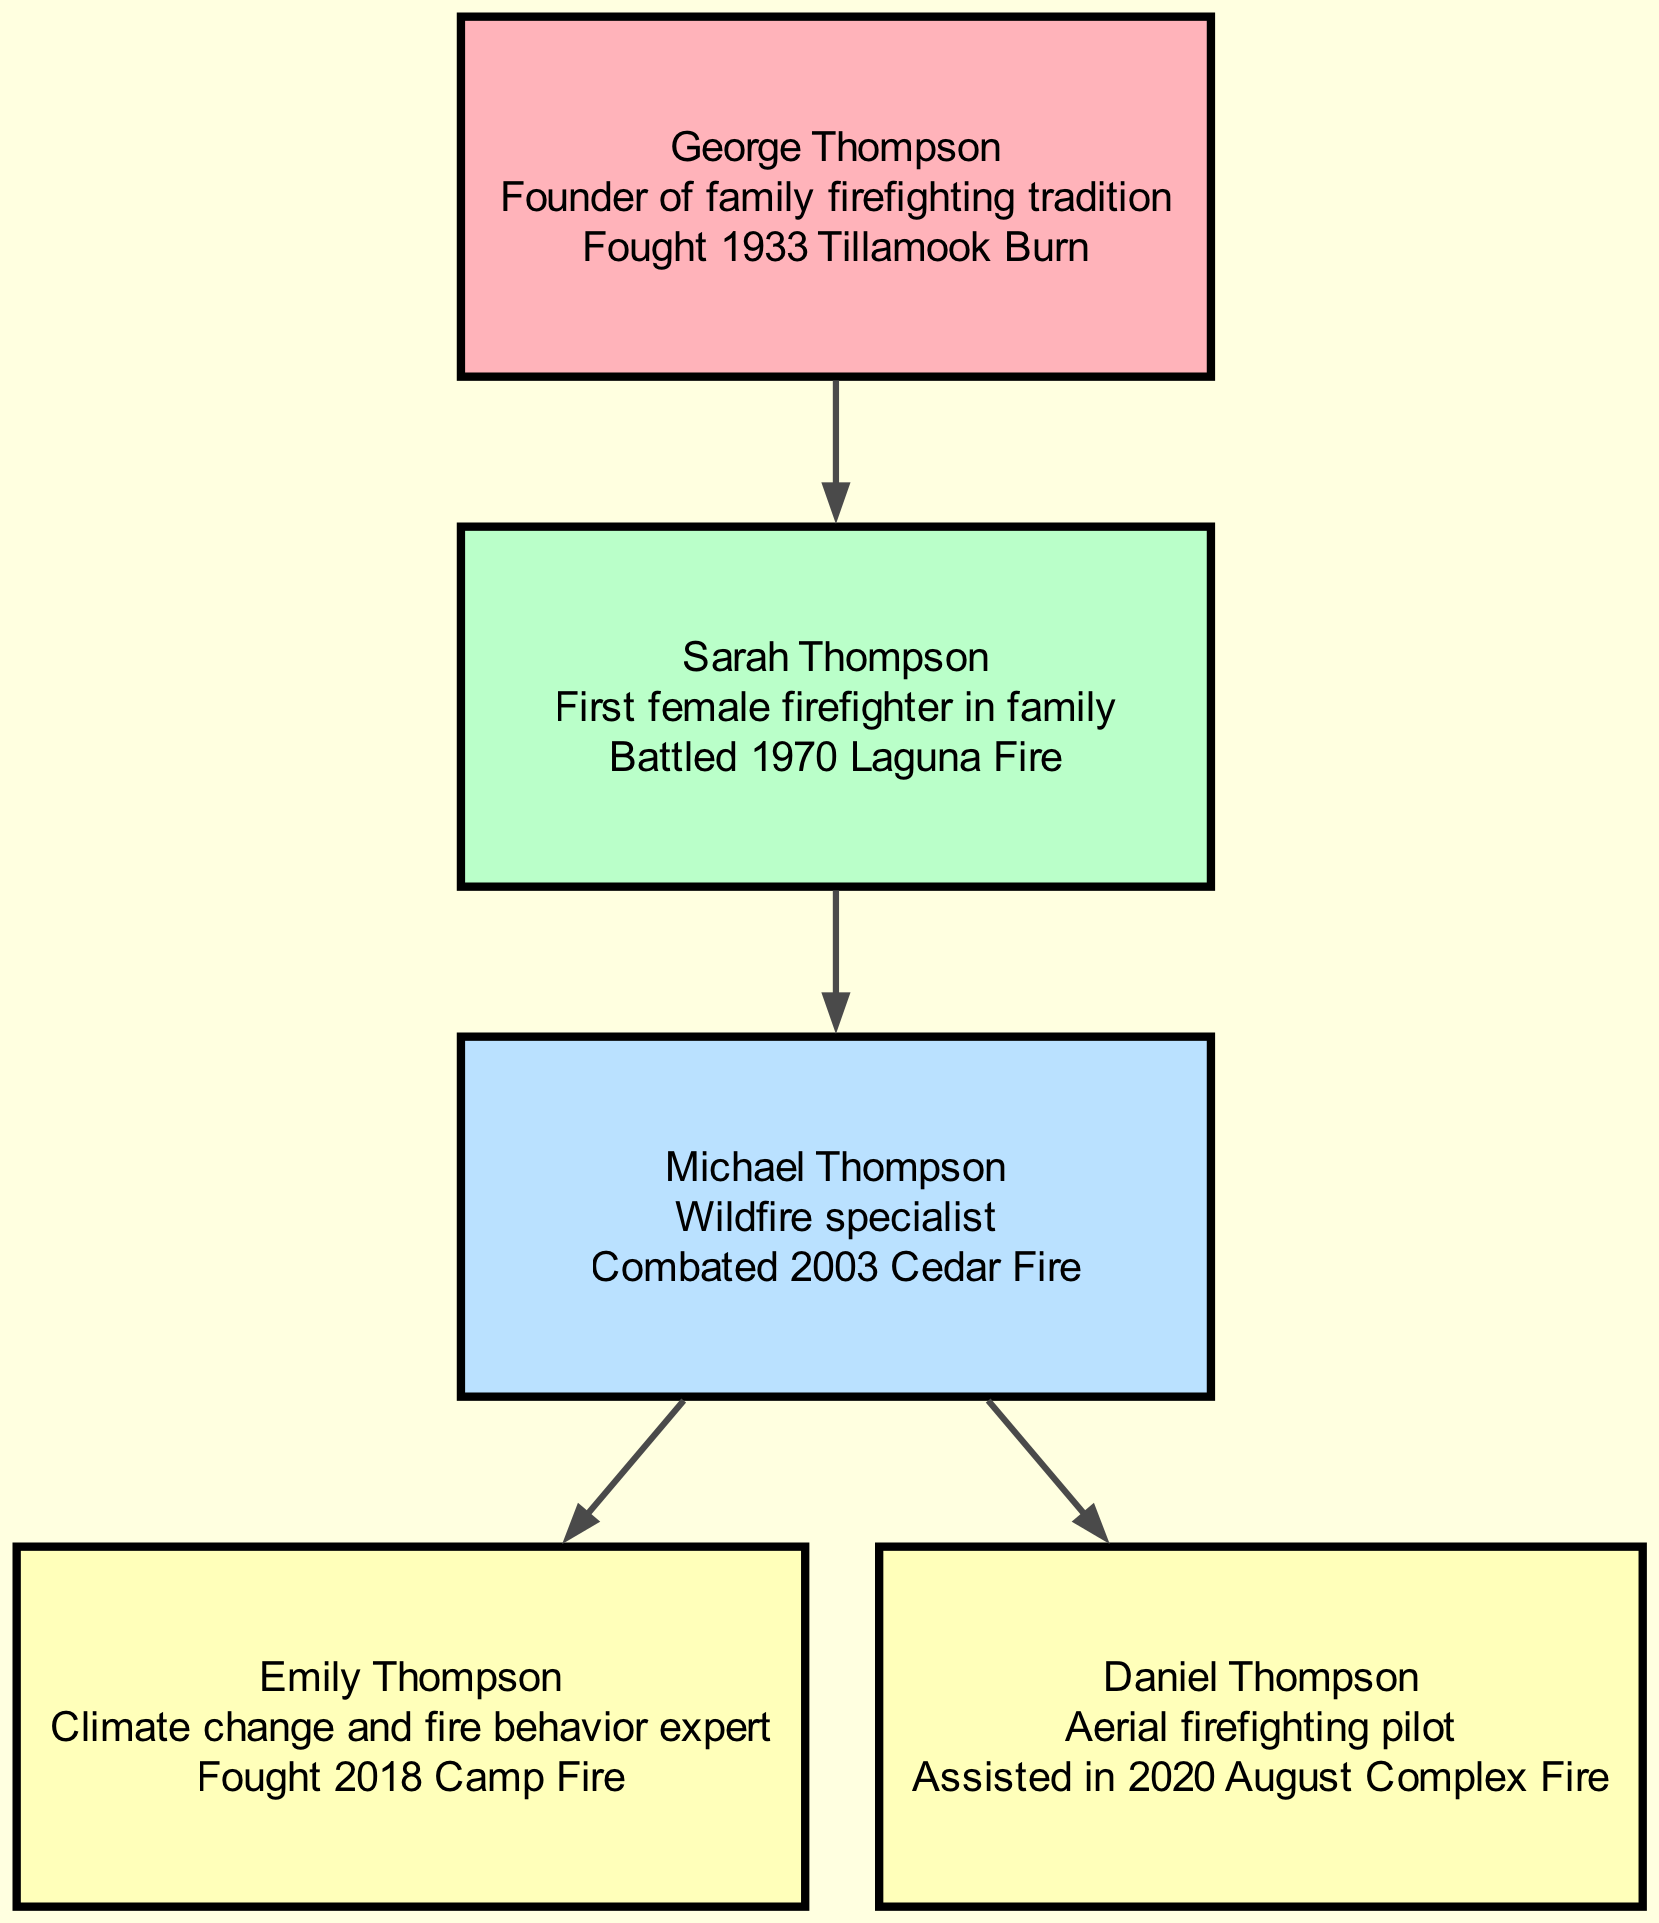What is the role of George Thompson? George Thompson is noted as the "Founder of family firefighting tradition." This role is clearly displayed in the diagram next to his name.
Answer: Founder of family firefighting tradition How many generations are represented in this family tree? The family tree contains members from four generations, specifically denoted by the numbers associated with each family member: 1, 2, 3, and 4.
Answer: 4 Who fought the 2003 Cedar Fire? The diagram specifies that Michael Thompson is the family member associated with "Combated 2003 Cedar Fire." This is directly stated in his information box.
Answer: Michael Thompson What relationship does Sarah Thompson have with George Thompson? The relationship is listed in the diagram as "Parent-Child," showing that Sarah is the child of George Thompson.
Answer: Parent-Child Which family member is an aerial firefighting pilot? The diagram identifies Daniel Thompson with the role of "Aerial firefighting pilot," making it clear who holds this title in the family.
Answer: Daniel Thompson Who is the climate change and fire behavior expert? The diagram indicates that Emily Thompson holds the title of "Climate change and fire behavior expert," which is specified in her information section.
Answer: Emily Thompson How many notable events are listed in total? The diagram provides a notable event for each of the five family members, which sums up to five notable events in total.
Answer: 5 Which generation does Sarah Thompson belong to? The diagram shows that Sarah Thompson is in the second generation, as indicated by the generation number assigned to her in the family structure.
Answer: 2 Who is the parent of Emily Thompson? According to the diagram, Michael Thompson is listed as the "Parent-Child" relationship for Emily Thompson, indicating that he is her parent.
Answer: Michael Thompson 